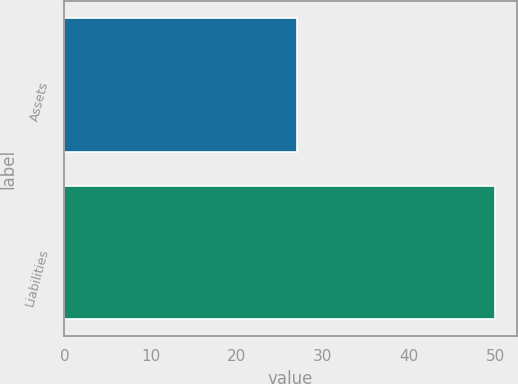<chart> <loc_0><loc_0><loc_500><loc_500><bar_chart><fcel>Assets<fcel>Liabilities<nl><fcel>27<fcel>50<nl></chart> 